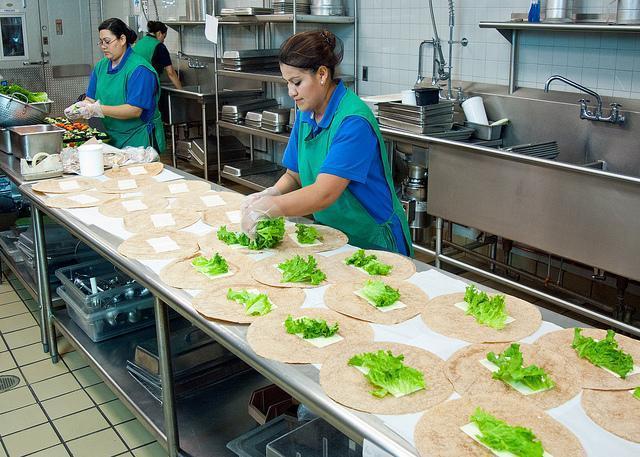How many people are there?
Give a very brief answer. 2. 